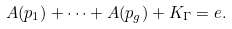Convert formula to latex. <formula><loc_0><loc_0><loc_500><loc_500>A ( p _ { 1 } ) + \dots + A ( p _ { g } ) + K _ { \Gamma } = e .</formula> 